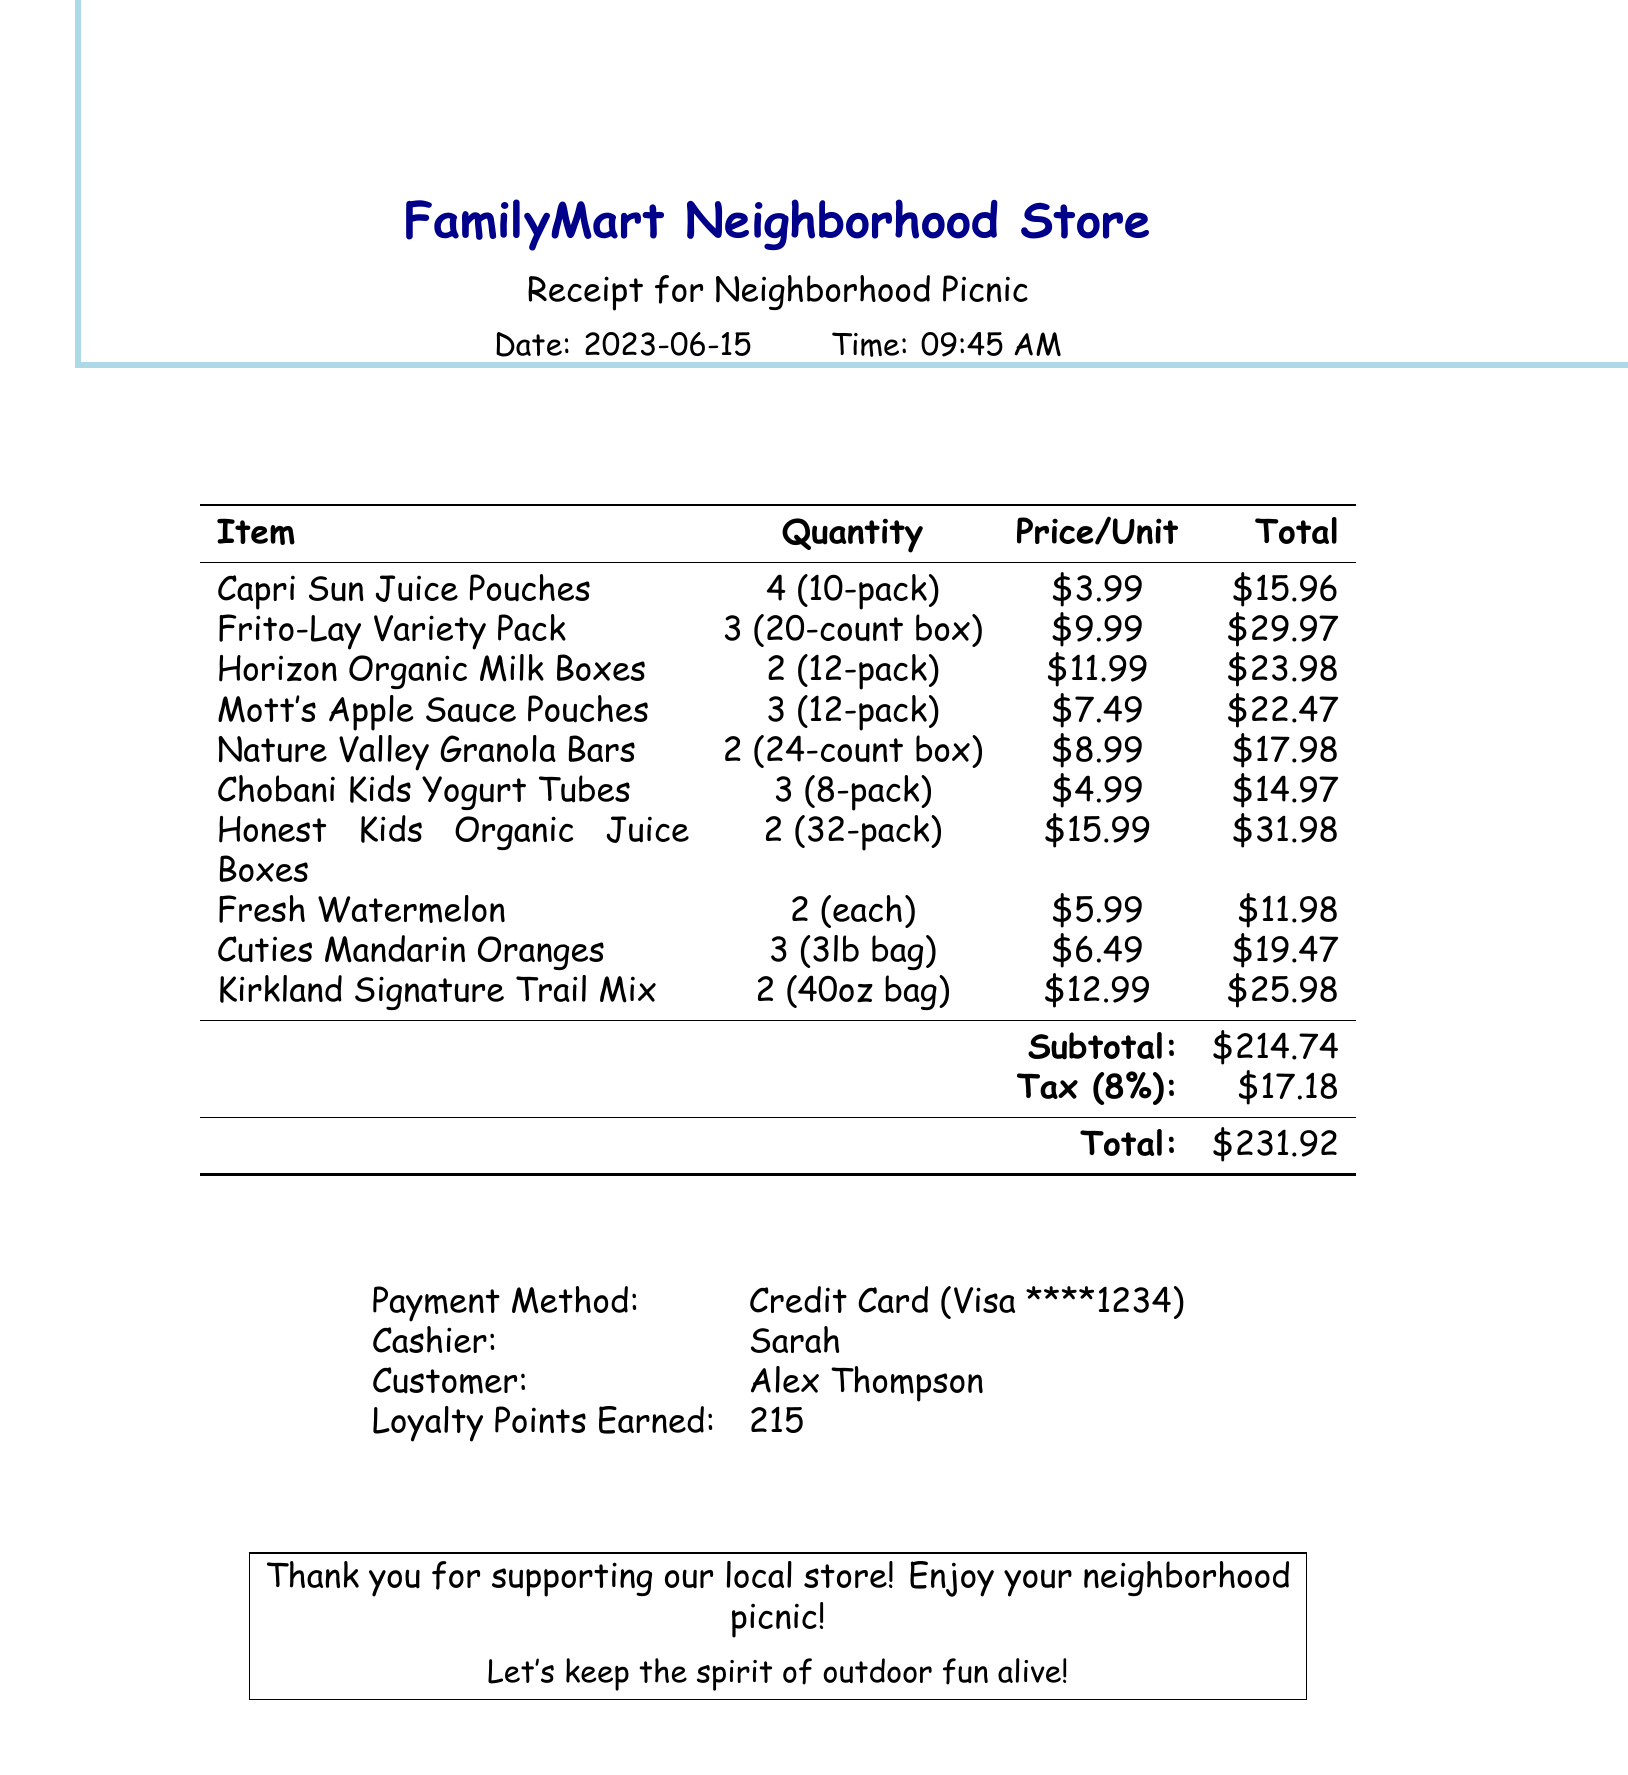What is the store name? The store name is mentioned at the top of the receipt.
Answer: FamilyMart Neighborhood Store What date was the purchase made? The purchase date is noted on the receipt under the date section.
Answer: 2023-06-15 Who was the cashier? The name of the cashier is listed in the payment details section of the receipt.
Answer: Sarah How many Capri Sun Juice Pouches were purchased? The quantity of Capri Sun Juice Pouches is specified in the items list on the receipt.
Answer: 4 What is the total cost including tax? The total cost is shown at the bottom of the receipt after calculating the subtotal and tax.
Answer: 231.92 What item had the highest total price? Comparing total prices of all items, the one with the highest value is indicated in the items list.
Answer: Honest Kids Organic Juice Boxes How much was earned in loyalty points? The loyalty points earned is stated in the payment details section.
Answer: 215 What type of payment was used? The payment method is clearly outlined on the receipt.
Answer: Credit Card Which item is in a 20-count box? The item description includes the unit for each listed item; the one that matches is noted.
Answer: Frito-Lay Variety Pack 